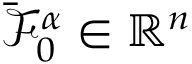<formula> <loc_0><loc_0><loc_500><loc_500>\bar { \mathcal { F } } _ { 0 } ^ { \alpha } \in \mathbb { R } ^ { n }</formula> 